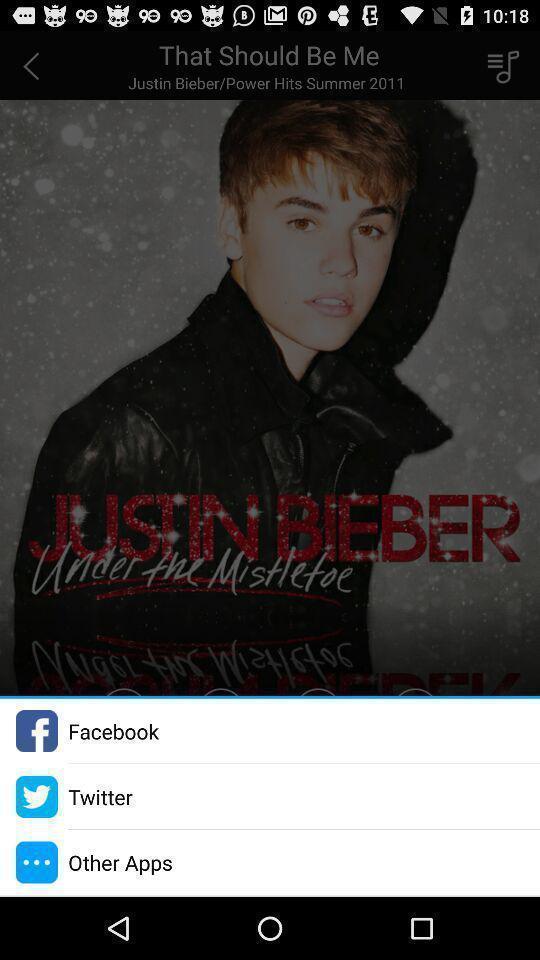Provide a description of this screenshot. Pop-up displaying multiple social apps to share. 